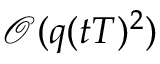Convert formula to latex. <formula><loc_0><loc_0><loc_500><loc_500>\mathcal { O } ( q ( t T ) ^ { 2 } )</formula> 